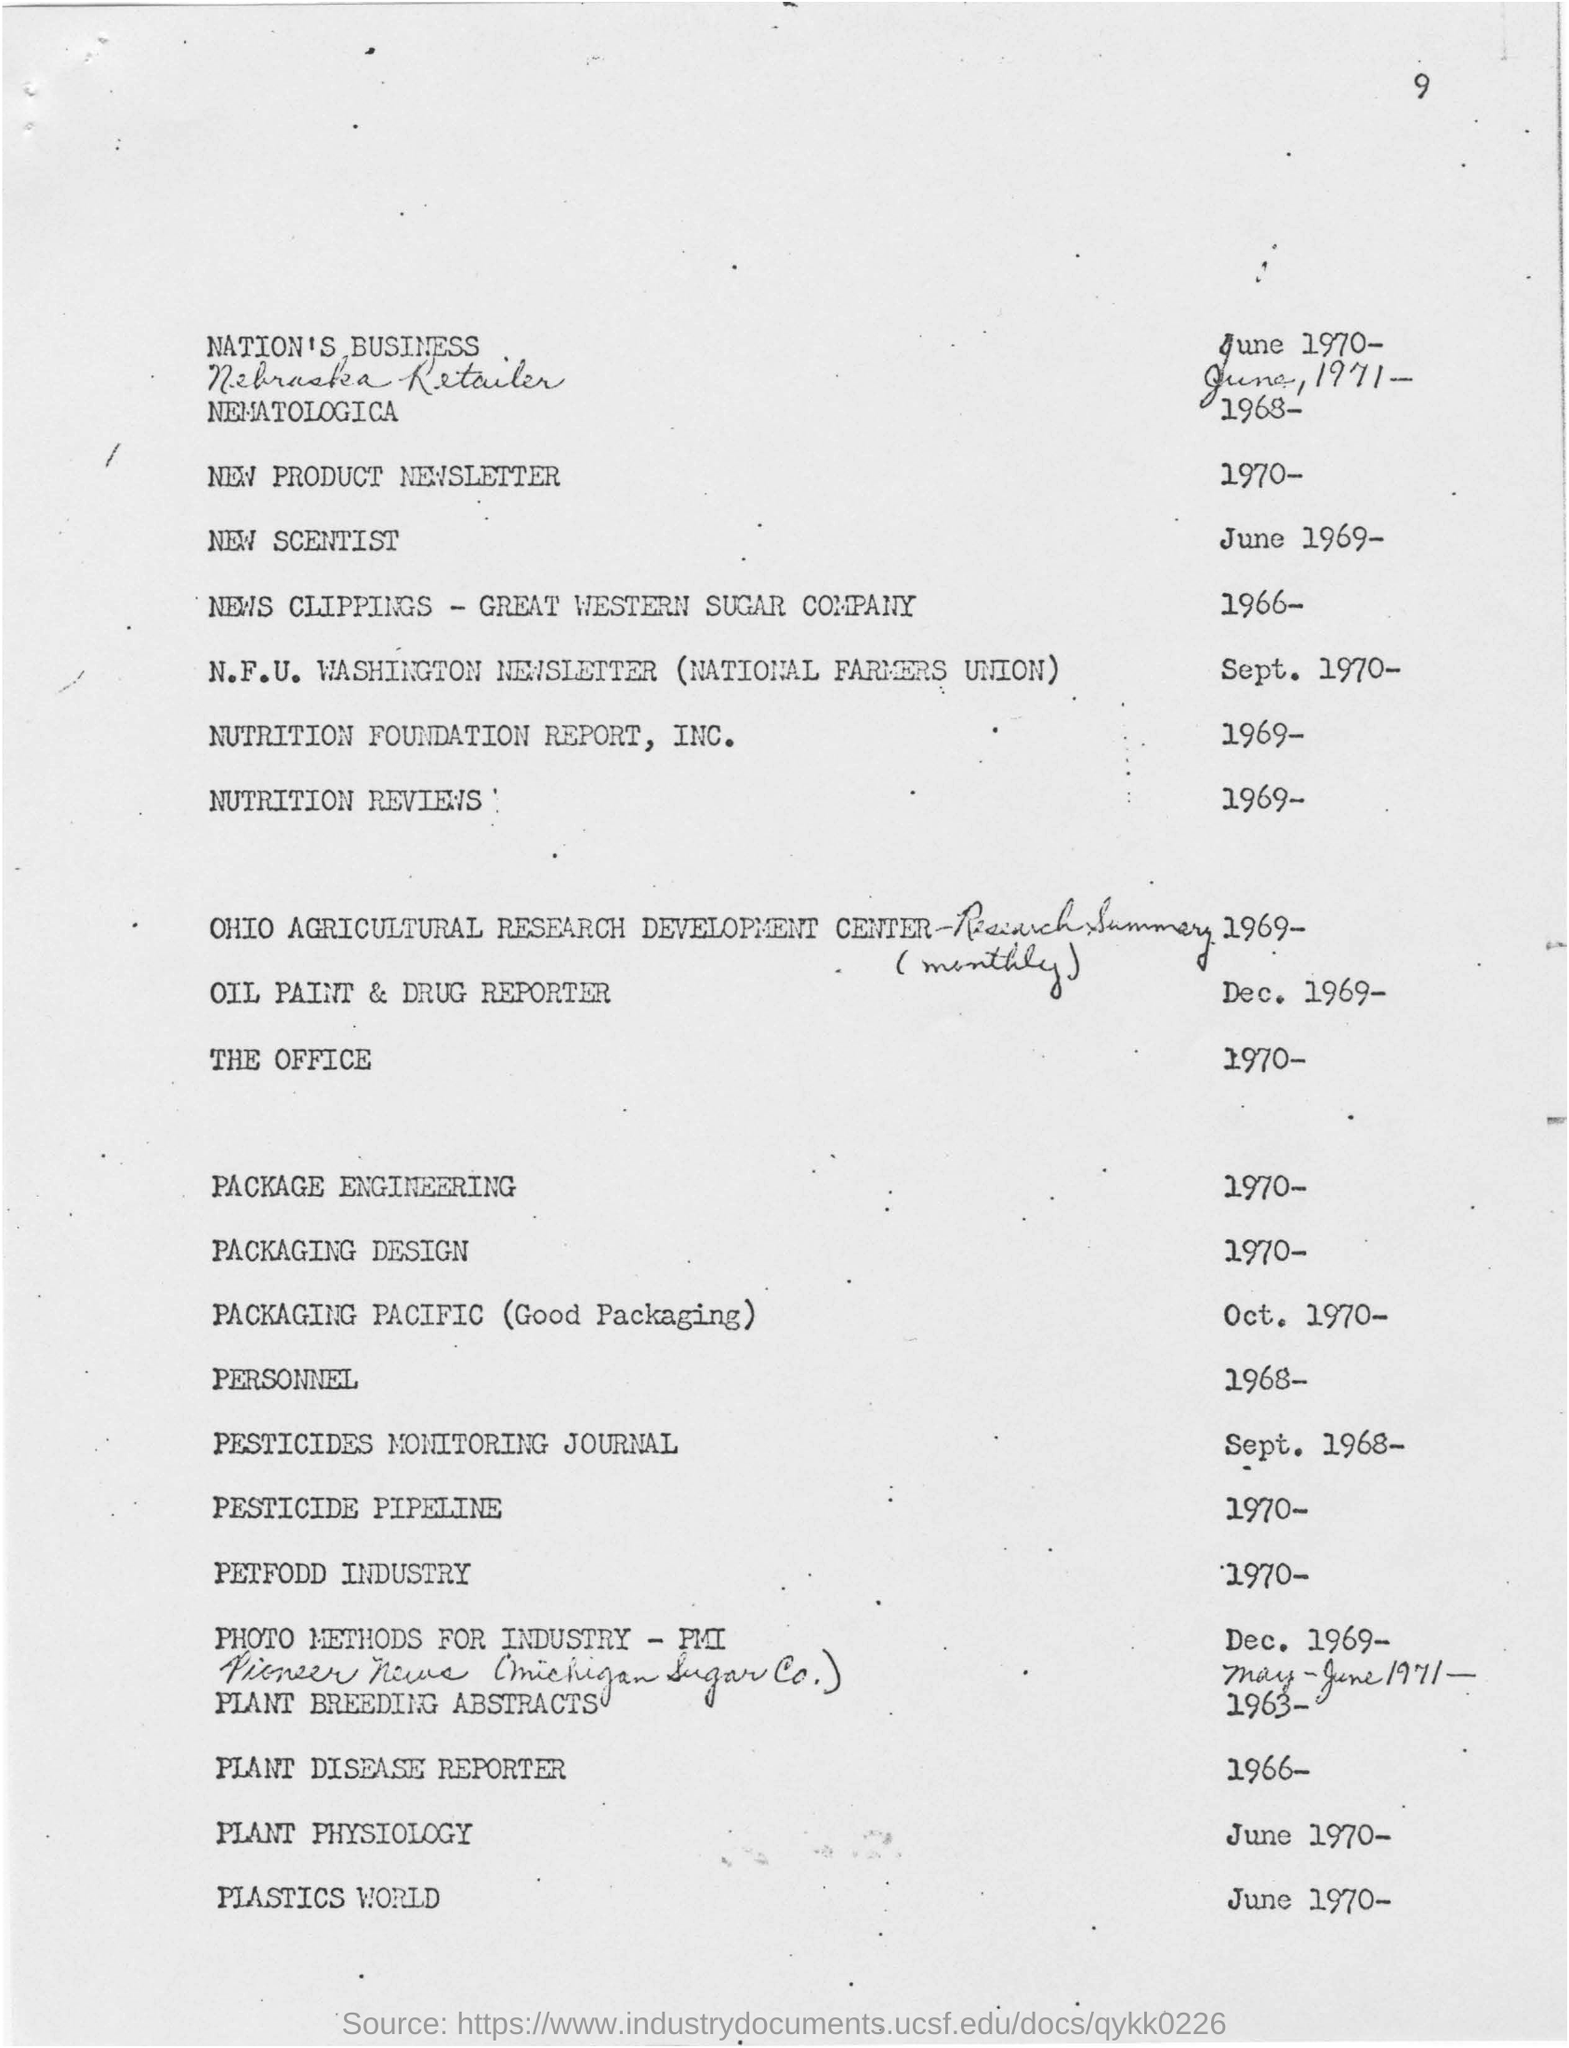Mention a couple of crucial points in this snapshot. The page number is 9. The New Scientist dated to June 1969. The Plastics World was dated from June 1970 until.. 